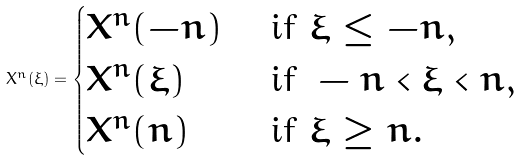Convert formula to latex. <formula><loc_0><loc_0><loc_500><loc_500>X ^ { n } ( \xi ) = \begin{cases} X ^ { n } ( - n ) & \text { if } \xi \leq - n , \\ X ^ { n } ( \xi ) & \text { if } - n < \xi < n , \\ X ^ { n } ( n ) & \text { if } \xi \geq n . \end{cases}</formula> 